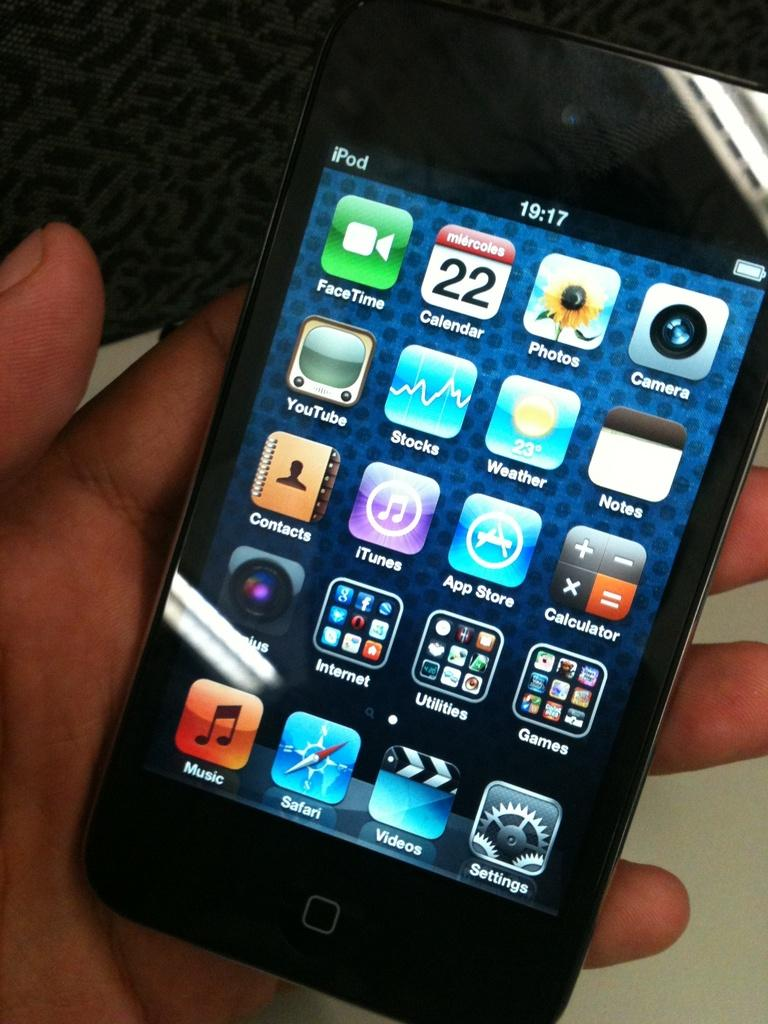<image>
Describe the image concisely. a hand is holding a black touchscreen ipod with the homescreen on the screen 